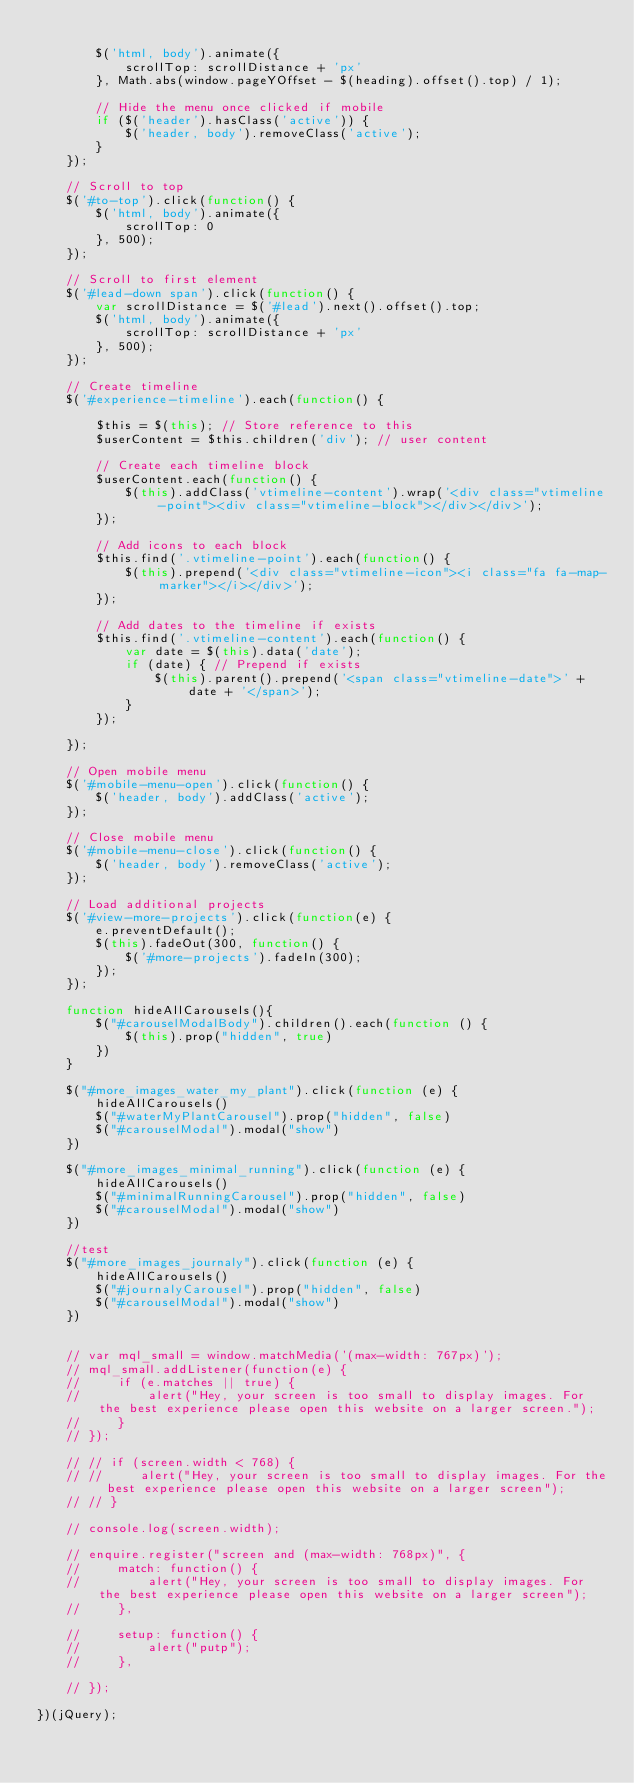<code> <loc_0><loc_0><loc_500><loc_500><_JavaScript_>
        $('html, body').animate({
            scrollTop: scrollDistance + 'px'
        }, Math.abs(window.pageYOffset - $(heading).offset().top) / 1);

        // Hide the menu once clicked if mobile
        if ($('header').hasClass('active')) {
            $('header, body').removeClass('active');
        }
    });

    // Scroll to top
    $('#to-top').click(function() {
        $('html, body').animate({
            scrollTop: 0
        }, 500);
    });

    // Scroll to first element
    $('#lead-down span').click(function() {
        var scrollDistance = $('#lead').next().offset().top;
        $('html, body').animate({
            scrollTop: scrollDistance + 'px'
        }, 500);
    });

    // Create timeline
    $('#experience-timeline').each(function() {

        $this = $(this); // Store reference to this
        $userContent = $this.children('div'); // user content

        // Create each timeline block
        $userContent.each(function() {
            $(this).addClass('vtimeline-content').wrap('<div class="vtimeline-point"><div class="vtimeline-block"></div></div>');
        });

        // Add icons to each block
        $this.find('.vtimeline-point').each(function() {
            $(this).prepend('<div class="vtimeline-icon"><i class="fa fa-map-marker"></i></div>');
        });

        // Add dates to the timeline if exists
        $this.find('.vtimeline-content').each(function() {
            var date = $(this).data('date');
            if (date) { // Prepend if exists
                $(this).parent().prepend('<span class="vtimeline-date">' + date + '</span>');
            }
        });

    });

    // Open mobile menu
    $('#mobile-menu-open').click(function() {
        $('header, body').addClass('active');
    });

    // Close mobile menu
    $('#mobile-menu-close').click(function() {
        $('header, body').removeClass('active');
    });

    // Load additional projects
    $('#view-more-projects').click(function(e) {
        e.preventDefault();
        $(this).fadeOut(300, function() {
            $('#more-projects').fadeIn(300);
        });
    });

    function hideAllCarousels(){
        $("#carouselModalBody").children().each(function () {
            $(this).prop("hidden", true)
        })
    }

    $("#more_images_water_my_plant").click(function (e) {
        hideAllCarousels()
        $("#waterMyPlantCarousel").prop("hidden", false)
        $("#carouselModal").modal("show")
    })

    $("#more_images_minimal_running").click(function (e) {
        hideAllCarousels()
        $("#minimalRunningCarousel").prop("hidden", false)
        $("#carouselModal").modal("show")
    })

    //test
    $("#more_images_journaly").click(function (e) {
        hideAllCarousels()
        $("#journalyCarousel").prop("hidden", false)
        $("#carouselModal").modal("show")
    })


    // var mql_small = window.matchMedia('(max-width: 767px)');
    // mql_small.addListener(function(e) {
    //     if (e.matches || true) {
    //         alert("Hey, your screen is too small to display images. For the best experience please open this website on a larger screen.");
    //     }
    // });

    // // if (screen.width < 768) {
    // //     alert("Hey, your screen is too small to display images. For the best experience please open this website on a larger screen");
    // // }

    // console.log(screen.width);

    // enquire.register("screen and (max-width: 768px)", {
    //     match: function() {
    //         alert("Hey, your screen is too small to display images. For the best experience please open this website on a larger screen");
    //     },

    //     setup: function() {
    //         alert("putp");
    //     },

    // });

})(jQuery);
</code> 